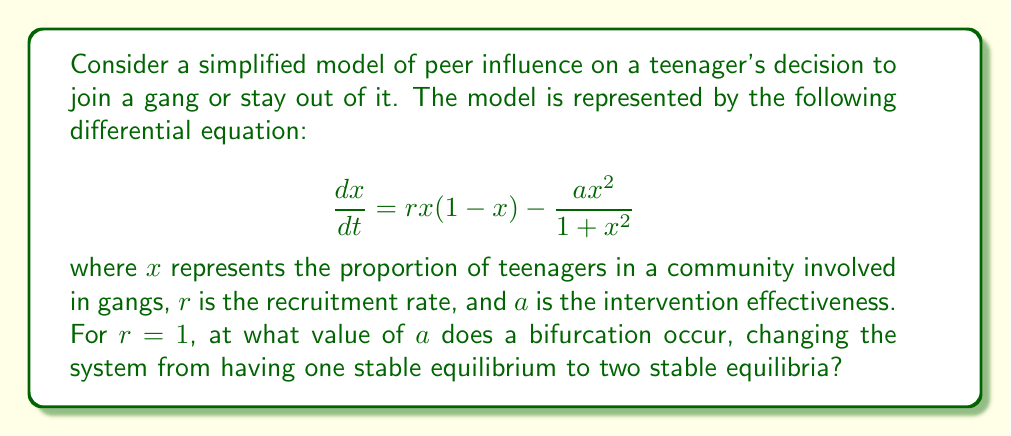Can you answer this question? To find the bifurcation point, we need to follow these steps:

1) First, find the equilibrium points by setting $\frac{dx}{dt} = 0$:

   $$rx(1-x) - \frac{ax^2}{1+x^2} = 0$$

2) For $r = 1$, this becomes:

   $$x(1-x) - \frac{ax^2}{1+x^2} = 0$$

3) Multiply both sides by $(1+x^2)$:

   $$x(1-x)(1+x^2) - ax^2 = 0$$

4) Expand:

   $$x + x^3 - x^2 - x^4 - ax^2 = 0$$

5) Rearrange:

   $$x^4 + (a-1)x^2 - x = 0$$

6) At the bifurcation point, this equation will have a double root. This occurs when the discriminant of the quadratic in $x^2$ is zero.

7) Let $y = x^2$. Then we have:

   $$y^2 + (a-1)y - x = 0$$

8) The discriminant of this quadratic is:

   $$(a-1)^2 + 4x = 0$$

9) At the bifurcation point, this should be true for some $x$. The smallest possible value for $x$ is 0, which gives:

   $$(a-1)^2 = 0$$

10) Solving this:

    $$a-1 = 0$$
    $$a = 1$$

Therefore, the bifurcation occurs when $a = 1$.
Answer: $a = 1$ 